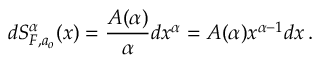<formula> <loc_0><loc_0><loc_500><loc_500>d S _ { F , a _ { o } } ^ { \alpha } ( x ) = \frac { A ( \alpha ) } { \alpha } d x ^ { \alpha } = A ( \alpha ) x ^ { \alpha - 1 } d x \, .</formula> 